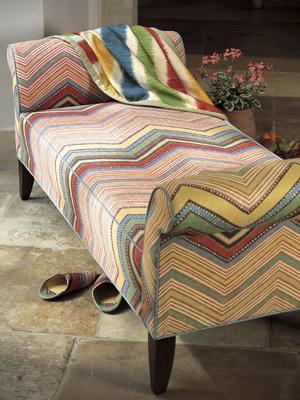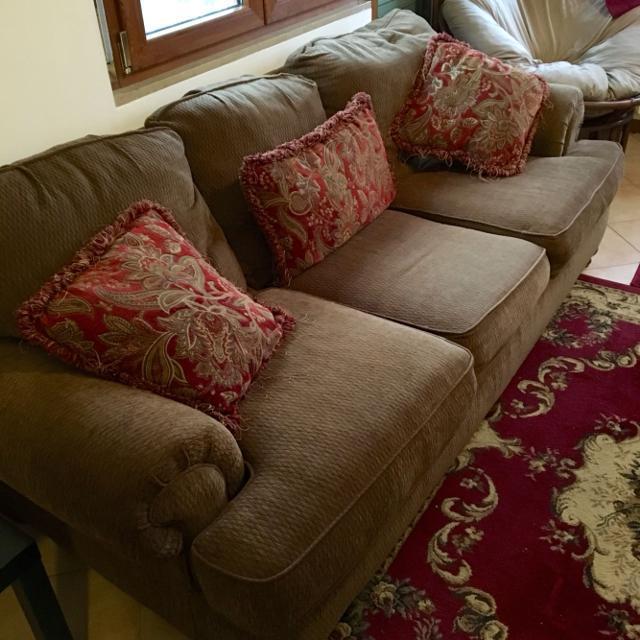The first image is the image on the left, the second image is the image on the right. Evaluate the accuracy of this statement regarding the images: "Three throw cushions sit on the sofa in the image on the right.". Is it true? Answer yes or no. Yes. The first image is the image on the left, the second image is the image on the right. Assess this claim about the two images: "The right image features multiple fringed pillows with a textured look and colors that include burgundy and brown.". Correct or not? Answer yes or no. Yes. 